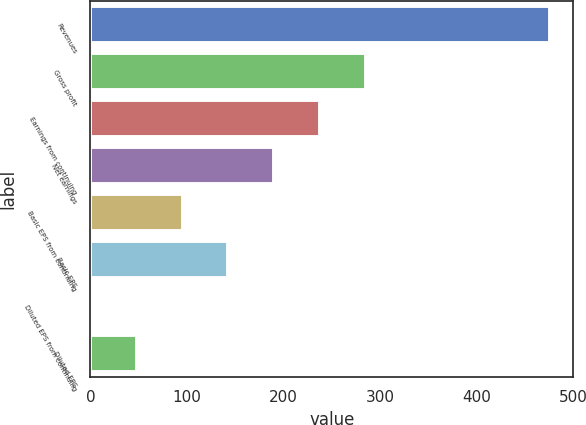<chart> <loc_0><loc_0><loc_500><loc_500><bar_chart><fcel>Revenues<fcel>Gross profit<fcel>Earnings from continuing<fcel>Net earnings<fcel>Basic EPS from continuing<fcel>Basic EPS<fcel>Diluted EPS from continuing<fcel>Diluted EPS<nl><fcel>476.4<fcel>285.91<fcel>238.28<fcel>190.65<fcel>95.39<fcel>143.02<fcel>0.13<fcel>47.76<nl></chart> 